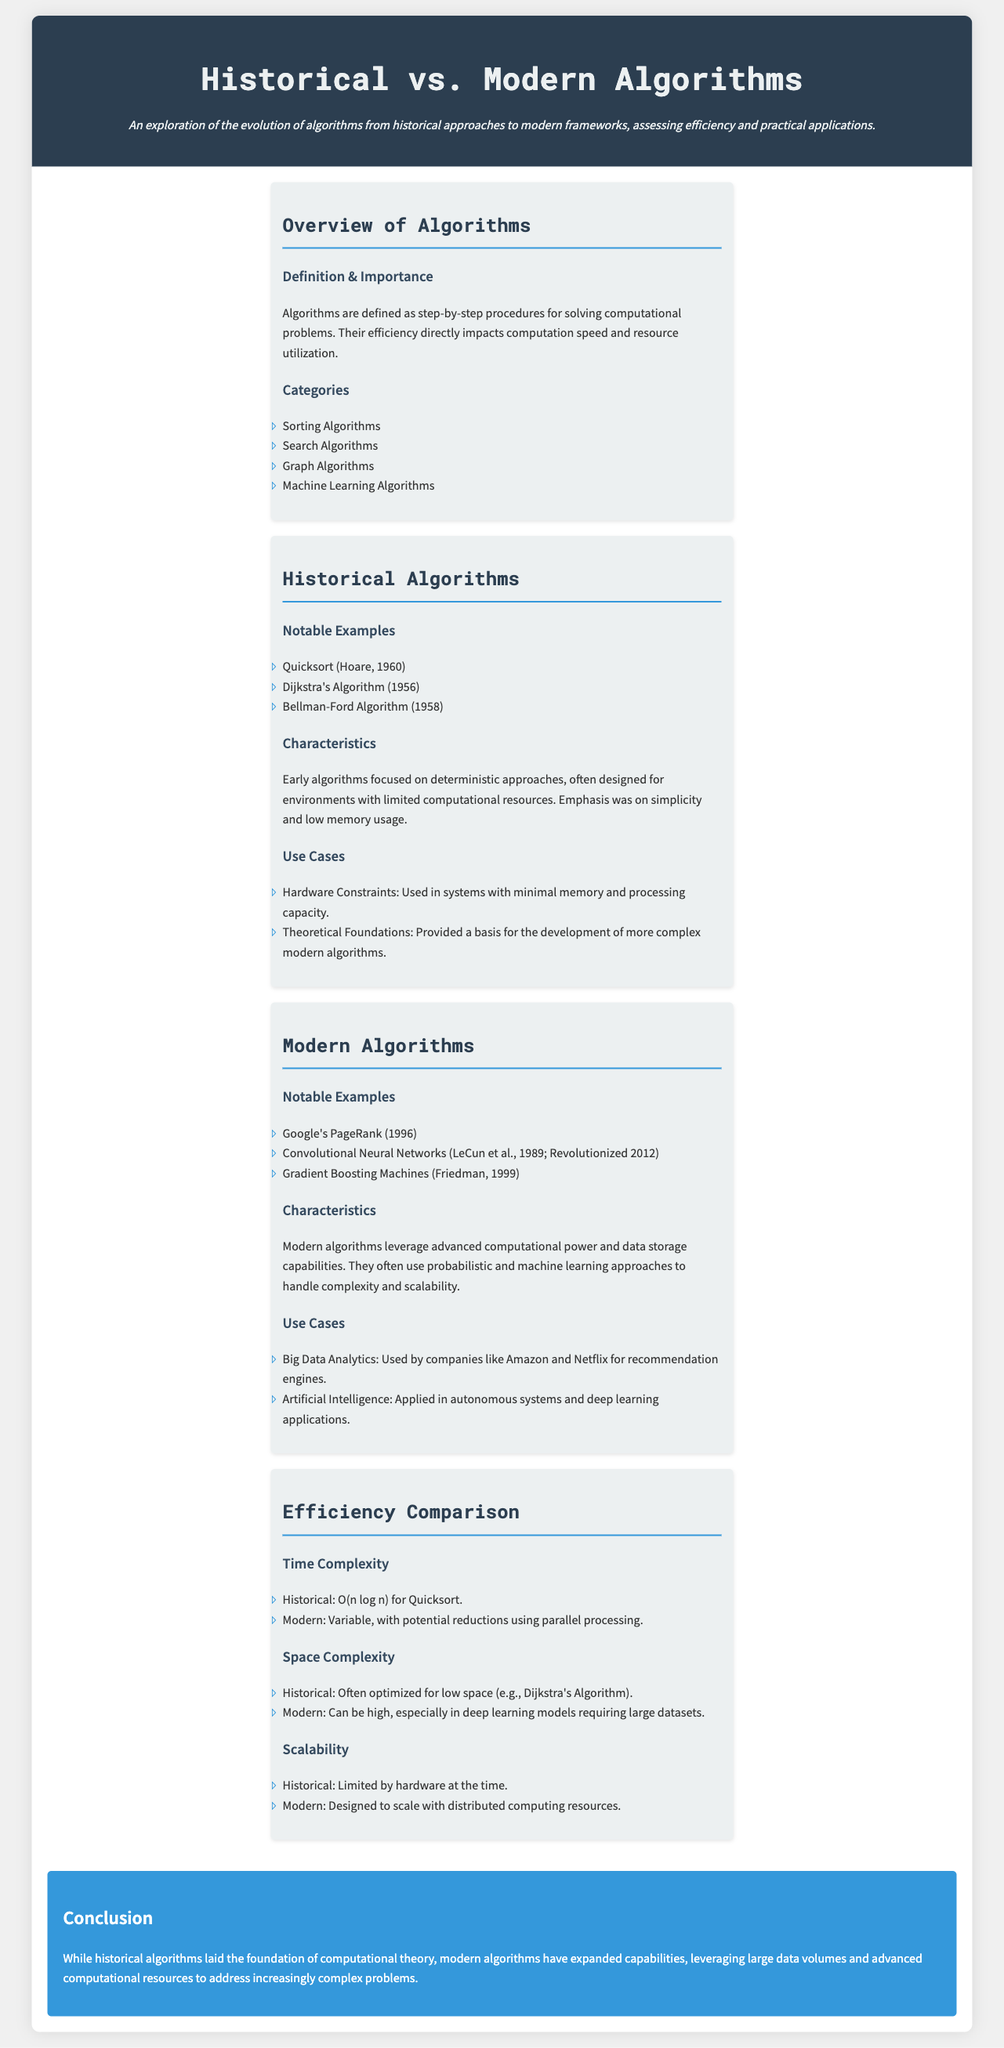What are the four categories of algorithms mentioned? The document lists sorting algorithms, search algorithms, graph algorithms, and machine learning algorithms as the four categories of algorithms.
Answer: Sorting, search, graph, machine learning Who developed Quicksort, and in what year? The document states that Quicksort was developed by Hoare in 1960.
Answer: Hoare, 1960 What algorithm is known for solving the shortest path problem and was created in 1956? The document designates Dijkstra's Algorithm, created in 1956, as the solution for the shortest path problem.
Answer: Dijkstra's Algorithm What is one characteristic of modern algorithms? The document highlights that modern algorithms leverage advanced computational power and data storage capabilities.
Answer: Advanced computational power What is the time complexity of Quicksort? According to the document, the time complexity of Quicksort is O(n log n).
Answer: O(n log n) How do historical algorithms typically optimize space? The document indicates that historical algorithms were often optimized for low space, such as in Dijkstra's Algorithm.
Answer: Low space What notable example of a modern algorithm revolutionized the field in 2012? The document states that Convolutional Neural Networks, revolutionized in 2012, is a notable modern algorithm.
Answer: Convolutional Neural Networks What is a common use case for modern algorithms mentioned in the document? The document references big data analytics as a common use case for modern algorithms, utilized by companies like Amazon and Netflix.
Answer: Big data analytics What are the two main aspects compared in efficiency? The document compares time complexity and space complexity regarding the efficiency of algorithms.
Answer: Time complexity, space complexity 